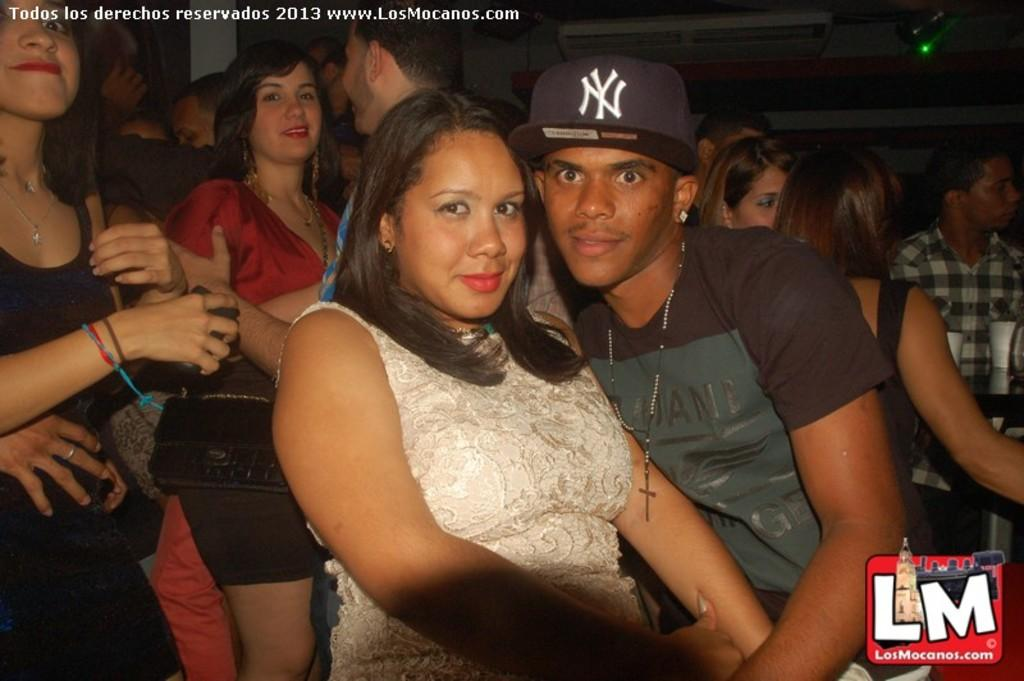How many individuals are present in the image? There is a group of people in the image. What type of knife is being used by the people in the image? There is no knife present in the image; it only shows a group of people. 